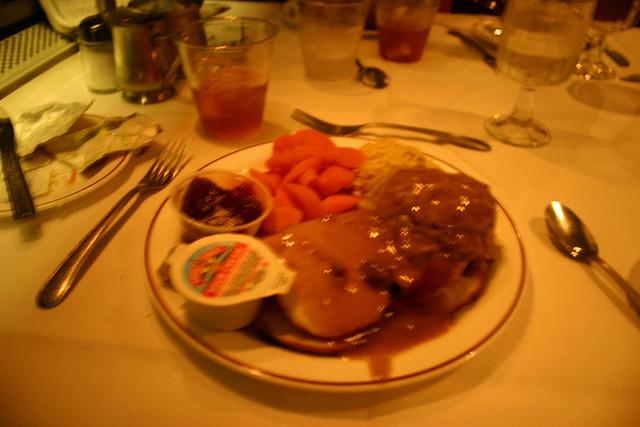What type of vegetables are on the plate?
Keep it brief. Carrots. What liquid is in the glass closest to the plate?
Quick response, please. Tea. How many forks are there?
Keep it brief. 2. 